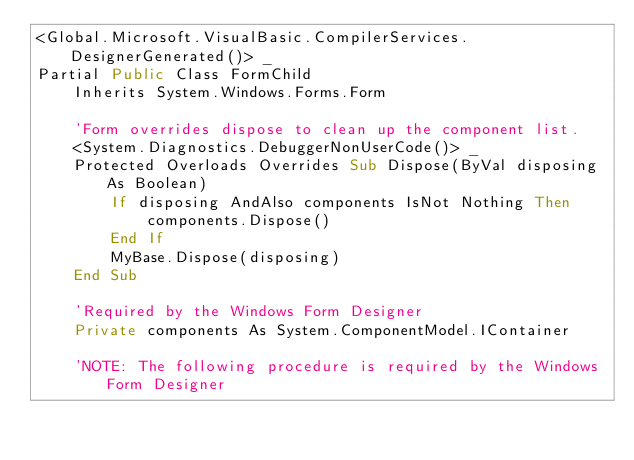<code> <loc_0><loc_0><loc_500><loc_500><_VisualBasic_><Global.Microsoft.VisualBasic.CompilerServices.DesignerGenerated()> _
Partial Public Class FormChild
    Inherits System.Windows.Forms.Form

    'Form overrides dispose to clean up the component list.
    <System.Diagnostics.DebuggerNonUserCode()> _
    Protected Overloads Overrides Sub Dispose(ByVal disposing As Boolean)
        If disposing AndAlso components IsNot Nothing Then
            components.Dispose()
        End If
        MyBase.Dispose(disposing)
    End Sub

    'Required by the Windows Form Designer
    Private components As System.ComponentModel.IContainer

    'NOTE: The following procedure is required by the Windows Form Designer</code> 